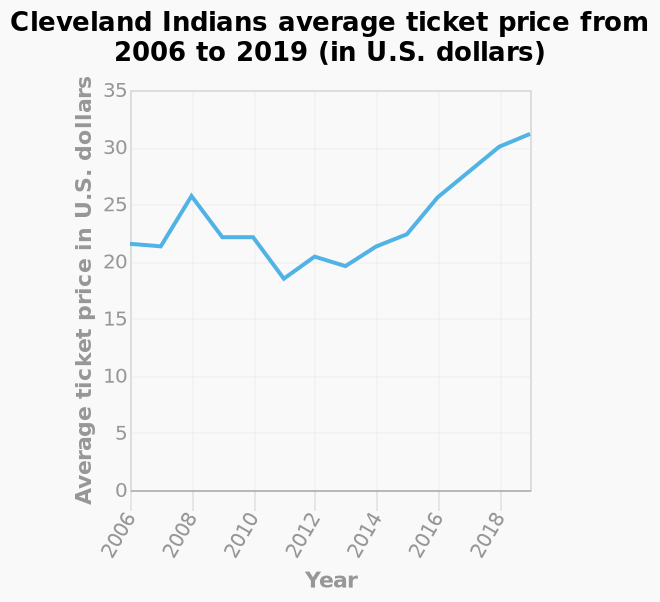<image>
What does the y-axis of the line chart represent? The y-axis of the line chart represents the average ticket price in U.S. dollars. Has there been a continuous increase in ticket prices since 2013? Yes, there has been a steady rise in prices since 2013. please describe the details of the chart Here a is a line chart labeled Cleveland Indians average ticket price from 2006 to 2019 (in U.S. dollars). The y-axis plots Average ticket price in U.S. dollars while the x-axis shows Year. Were the ticket prices consistent before 2013? Yes, the ticket prices remained steady until 2013. 